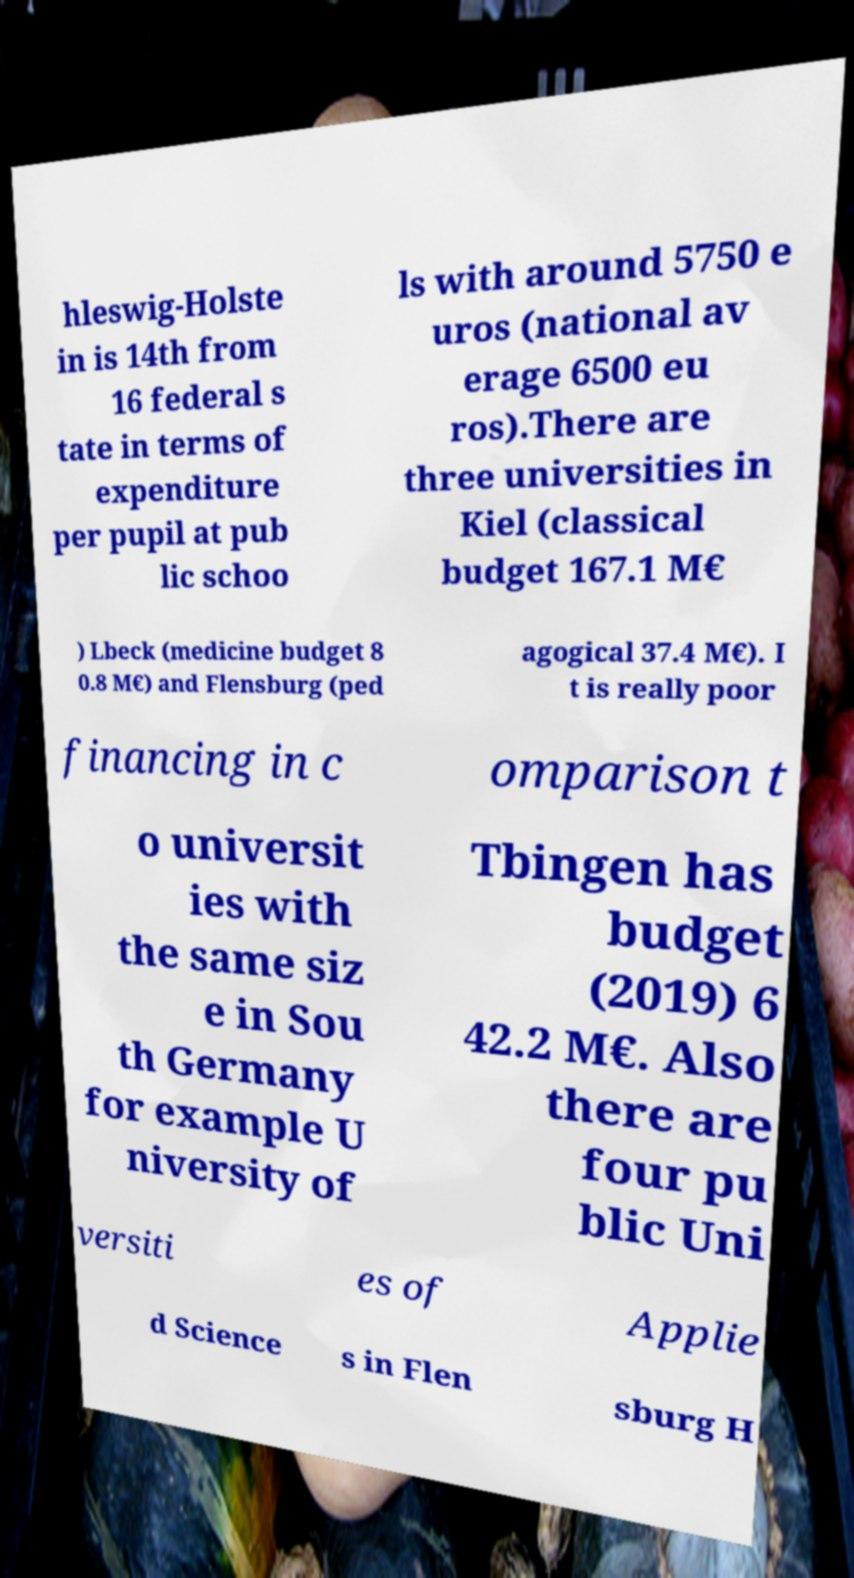Could you assist in decoding the text presented in this image and type it out clearly? hleswig-Holste in is 14th from 16 federal s tate in terms of expenditure per pupil at pub lic schoo ls with around 5750 e uros (national av erage 6500 eu ros).There are three universities in Kiel (classical budget 167.1 M€ ) Lbeck (medicine budget 8 0.8 M€) and Flensburg (ped agogical 37.4 M€). I t is really poor financing in c omparison t o universit ies with the same siz e in Sou th Germany for example U niversity of Tbingen has budget (2019) 6 42.2 M€. Also there are four pu blic Uni versiti es of Applie d Science s in Flen sburg H 